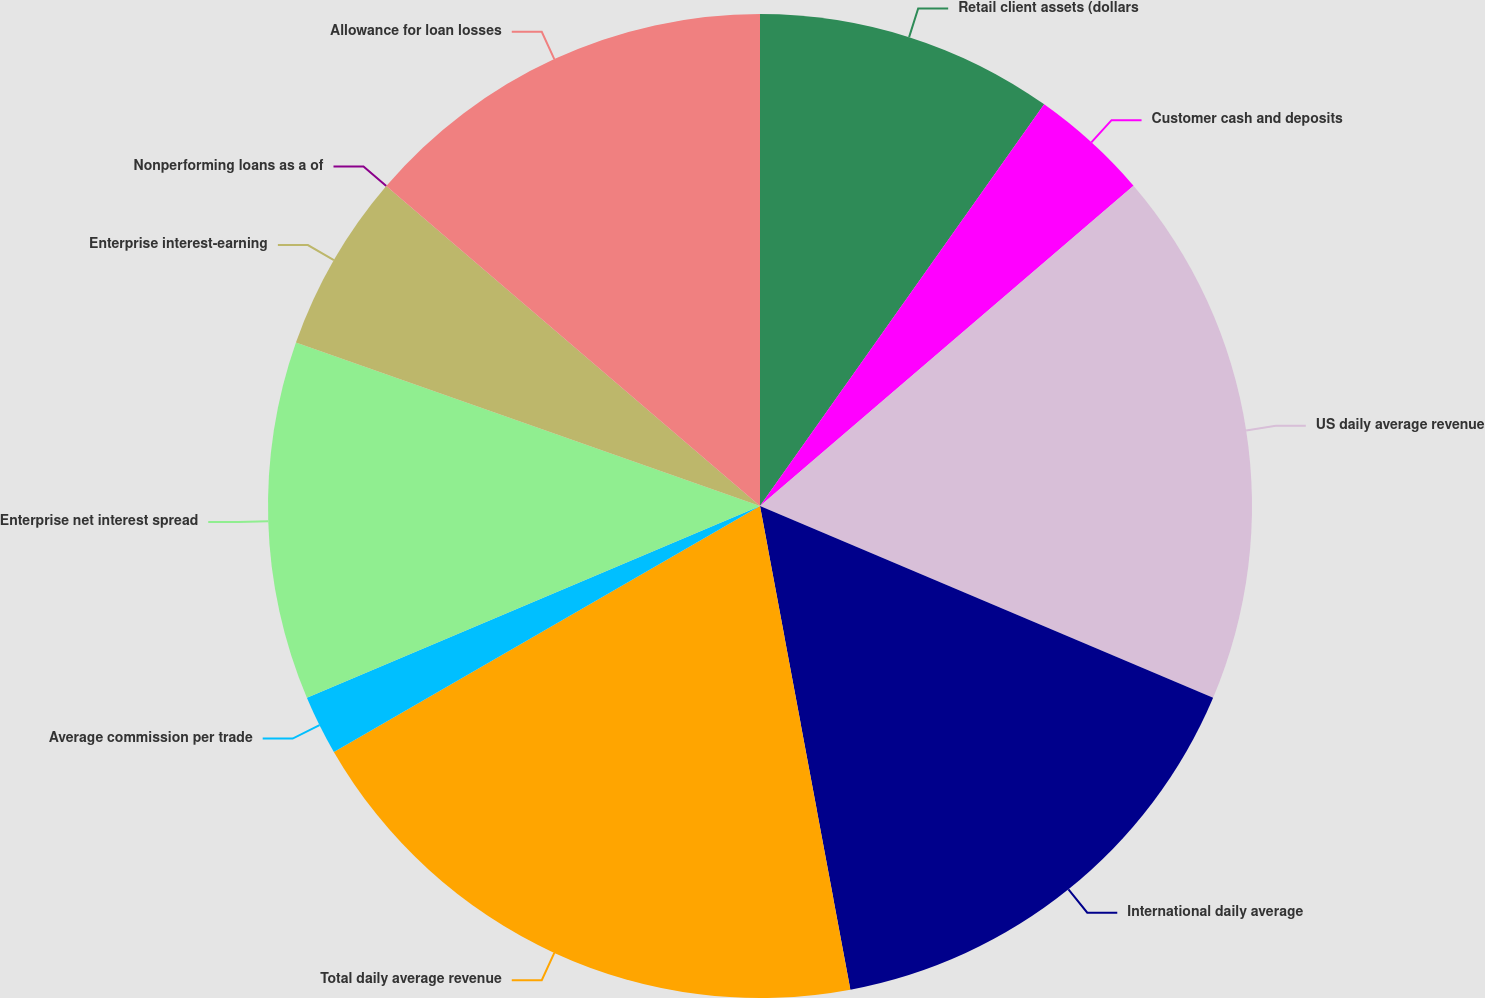<chart> <loc_0><loc_0><loc_500><loc_500><pie_chart><fcel>Retail client assets (dollars<fcel>Customer cash and deposits<fcel>US daily average revenue<fcel>International daily average<fcel>Total daily average revenue<fcel>Average commission per trade<fcel>Enterprise net interest spread<fcel>Enterprise interest-earning<fcel>Nonperforming loans as a of<fcel>Allowance for loan losses<nl><fcel>9.8%<fcel>3.92%<fcel>17.65%<fcel>15.69%<fcel>19.61%<fcel>1.96%<fcel>11.76%<fcel>5.88%<fcel>0.0%<fcel>13.73%<nl></chart> 